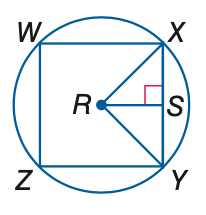Answer the mathemtical geometry problem and directly provide the correct option letter.
Question: In the figure, square W X Y Z is inscribed in \odot R. Find the measure of a central angle.
Choices: A: 45 B: 90 C: 180 D: 270 B 